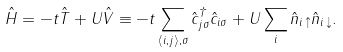Convert formula to latex. <formula><loc_0><loc_0><loc_500><loc_500>\hat { H } = - t \hat { T } + U \hat { V } \equiv - t \sum _ { \langle i , j \rangle , \sigma } \hat { c } ^ { \dagger } _ { j \sigma } \hat { c } _ { i \sigma } + U \sum _ { i } \hat { n } _ { i \, \uparrow } \hat { n } _ { i \, \downarrow } .</formula> 